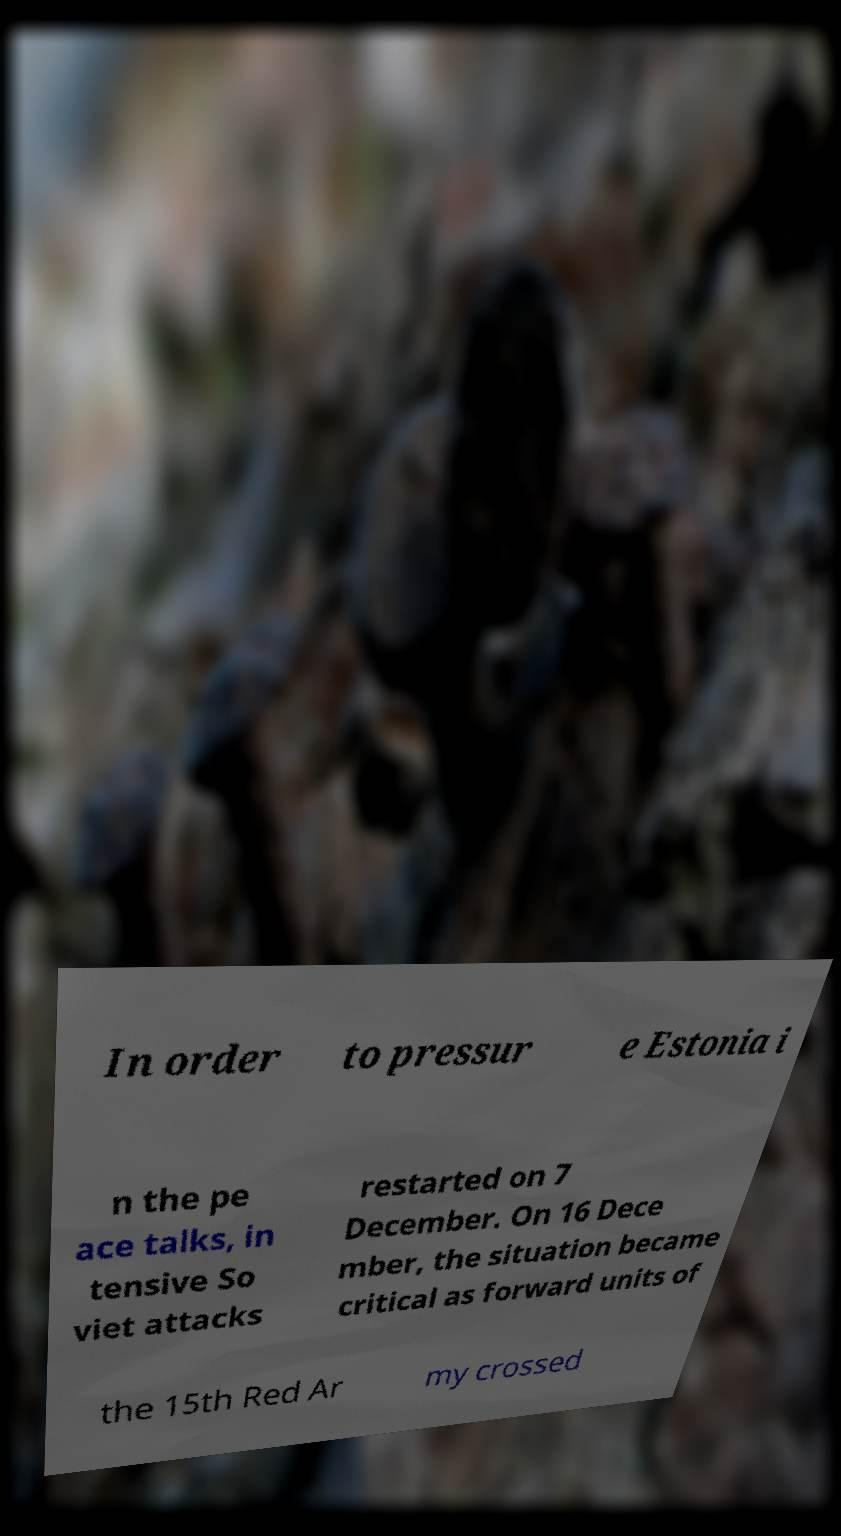For documentation purposes, I need the text within this image transcribed. Could you provide that? In order to pressur e Estonia i n the pe ace talks, in tensive So viet attacks restarted on 7 December. On 16 Dece mber, the situation became critical as forward units of the 15th Red Ar my crossed 